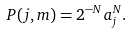<formula> <loc_0><loc_0><loc_500><loc_500>P ( j , m ) = 2 ^ { - N } a _ { j } ^ { N } .</formula> 